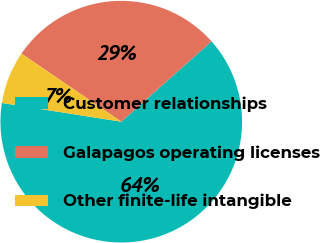Convert chart. <chart><loc_0><loc_0><loc_500><loc_500><pie_chart><fcel>Customer relationships<fcel>Galapagos operating licenses<fcel>Other finite-life intangible<nl><fcel>64.05%<fcel>28.9%<fcel>7.05%<nl></chart> 